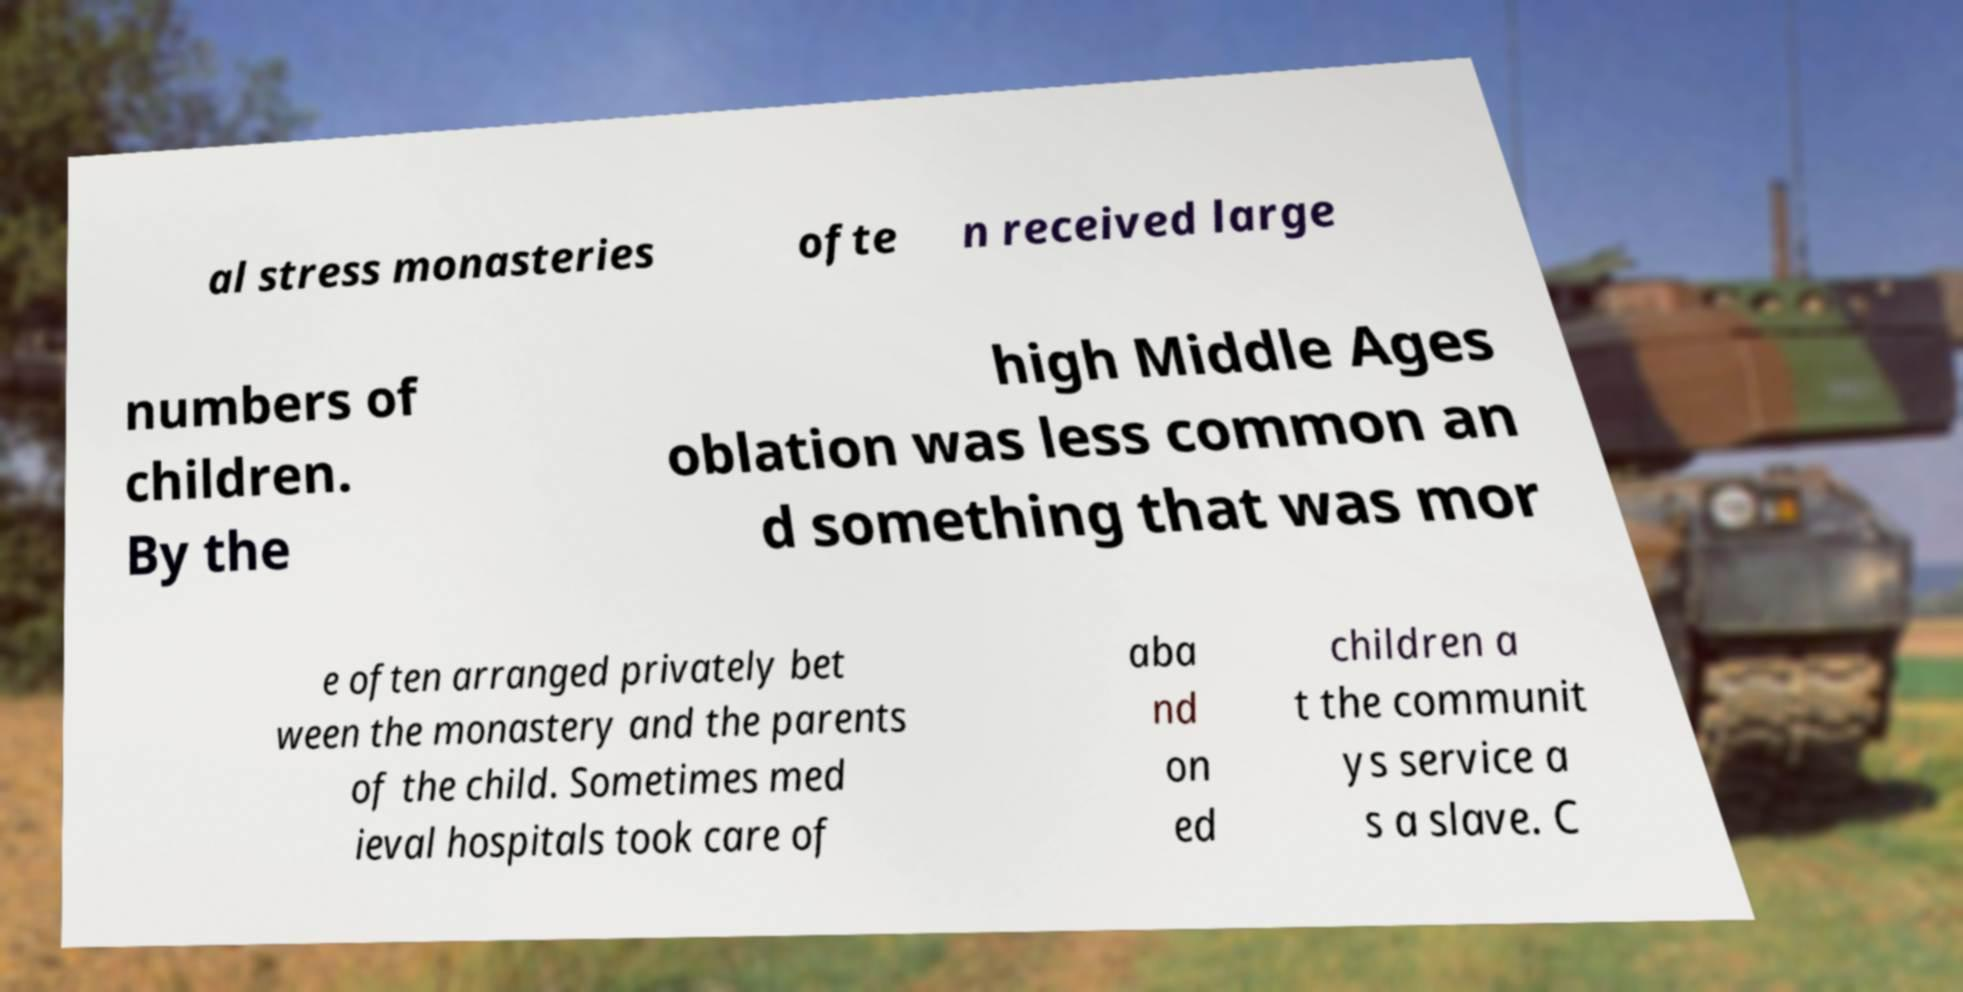Could you extract and type out the text from this image? al stress monasteries ofte n received large numbers of children. By the high Middle Ages oblation was less common an d something that was mor e often arranged privately bet ween the monastery and the parents of the child. Sometimes med ieval hospitals took care of aba nd on ed children a t the communit ys service a s a slave. C 